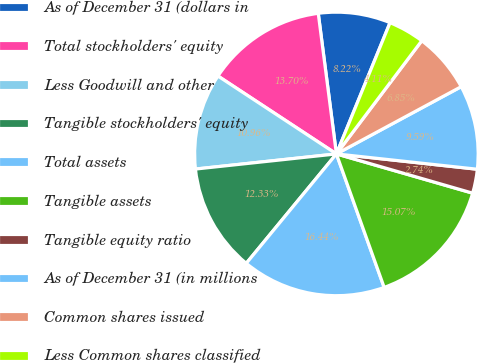Convert chart. <chart><loc_0><loc_0><loc_500><loc_500><pie_chart><fcel>As of December 31 (dollars in<fcel>Total stockholders' equity<fcel>Less Goodwill and other<fcel>Tangible stockholders' equity<fcel>Total assets<fcel>Tangible assets<fcel>Tangible equity ratio<fcel>As of December 31 (in millions<fcel>Common shares issued<fcel>Less Common shares classified<nl><fcel>8.22%<fcel>13.7%<fcel>10.96%<fcel>12.33%<fcel>16.44%<fcel>15.07%<fcel>2.74%<fcel>9.59%<fcel>6.85%<fcel>4.11%<nl></chart> 